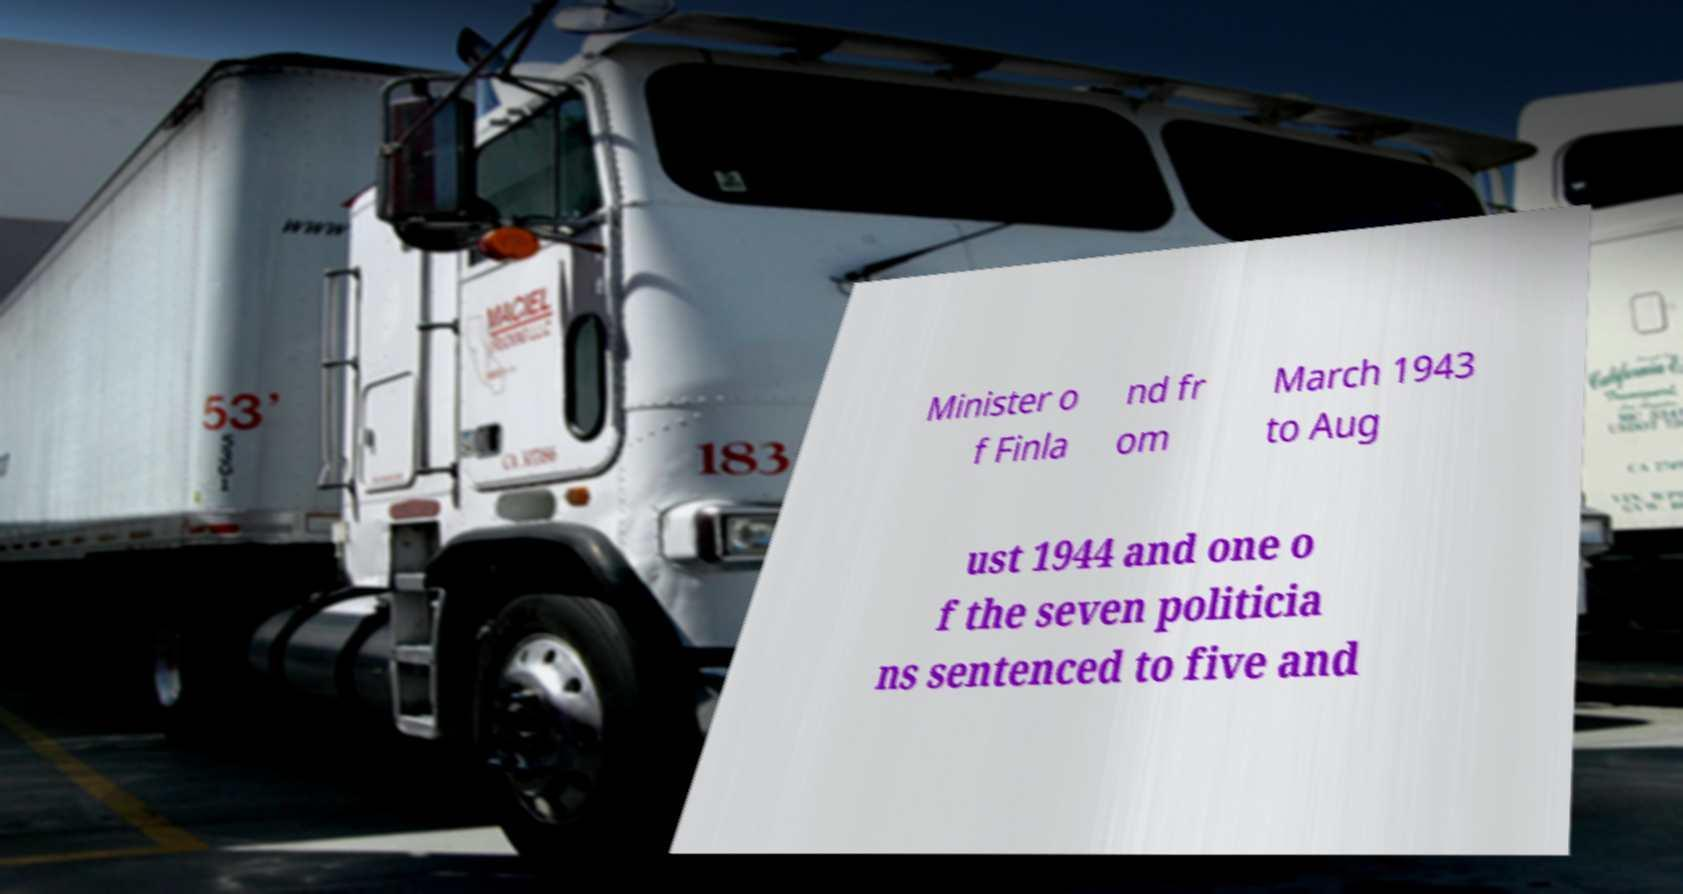Could you assist in decoding the text presented in this image and type it out clearly? Minister o f Finla nd fr om March 1943 to Aug ust 1944 and one o f the seven politicia ns sentenced to five and 